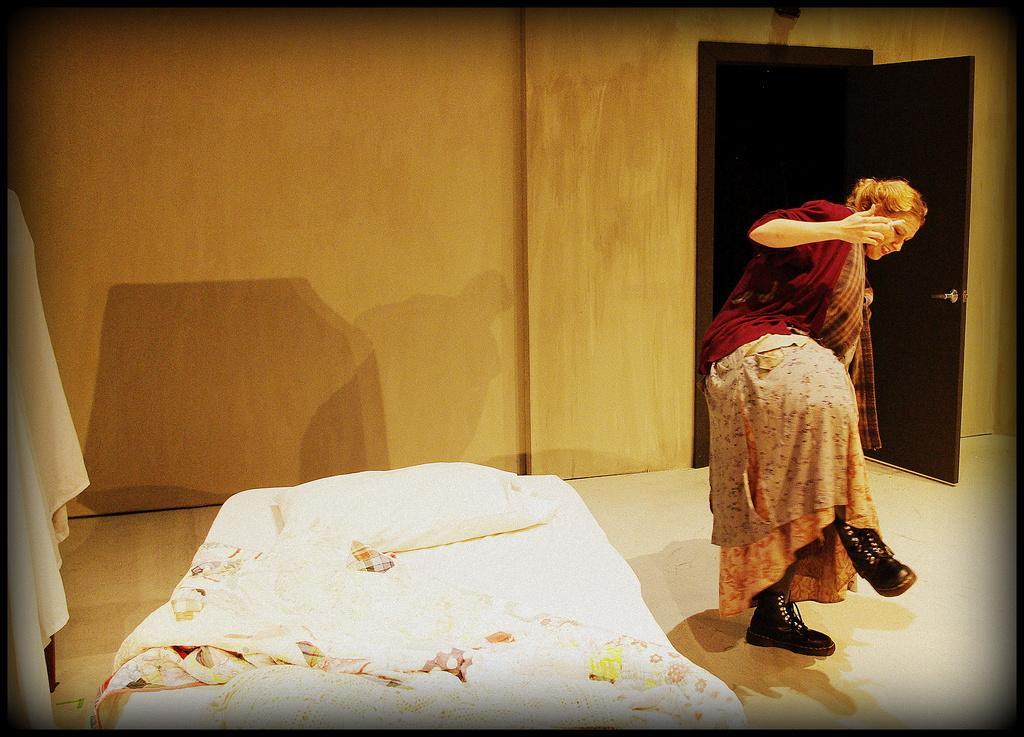Can you describe this image briefly? On this floor there is a bed, pillow and bed-sheet. This woman is standing. Background there is a wall and door. 